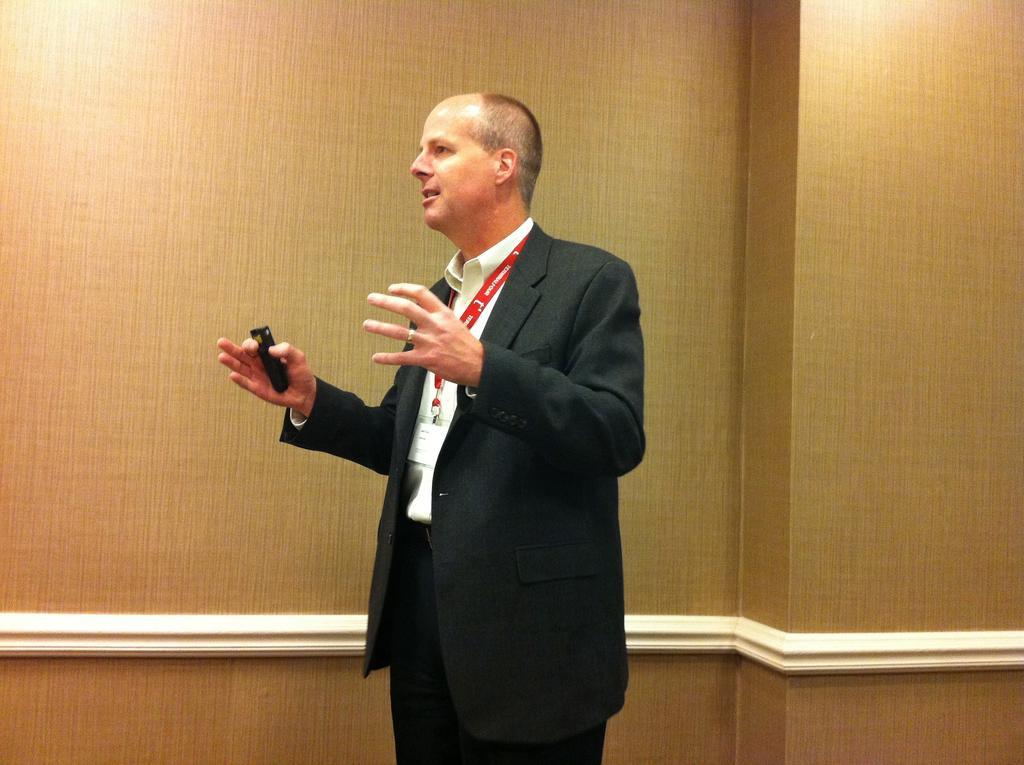Please provide a concise description of this image. In the center of this picture we can see a person wearing suit, holding an object and standing. In the background we can see the wall. 